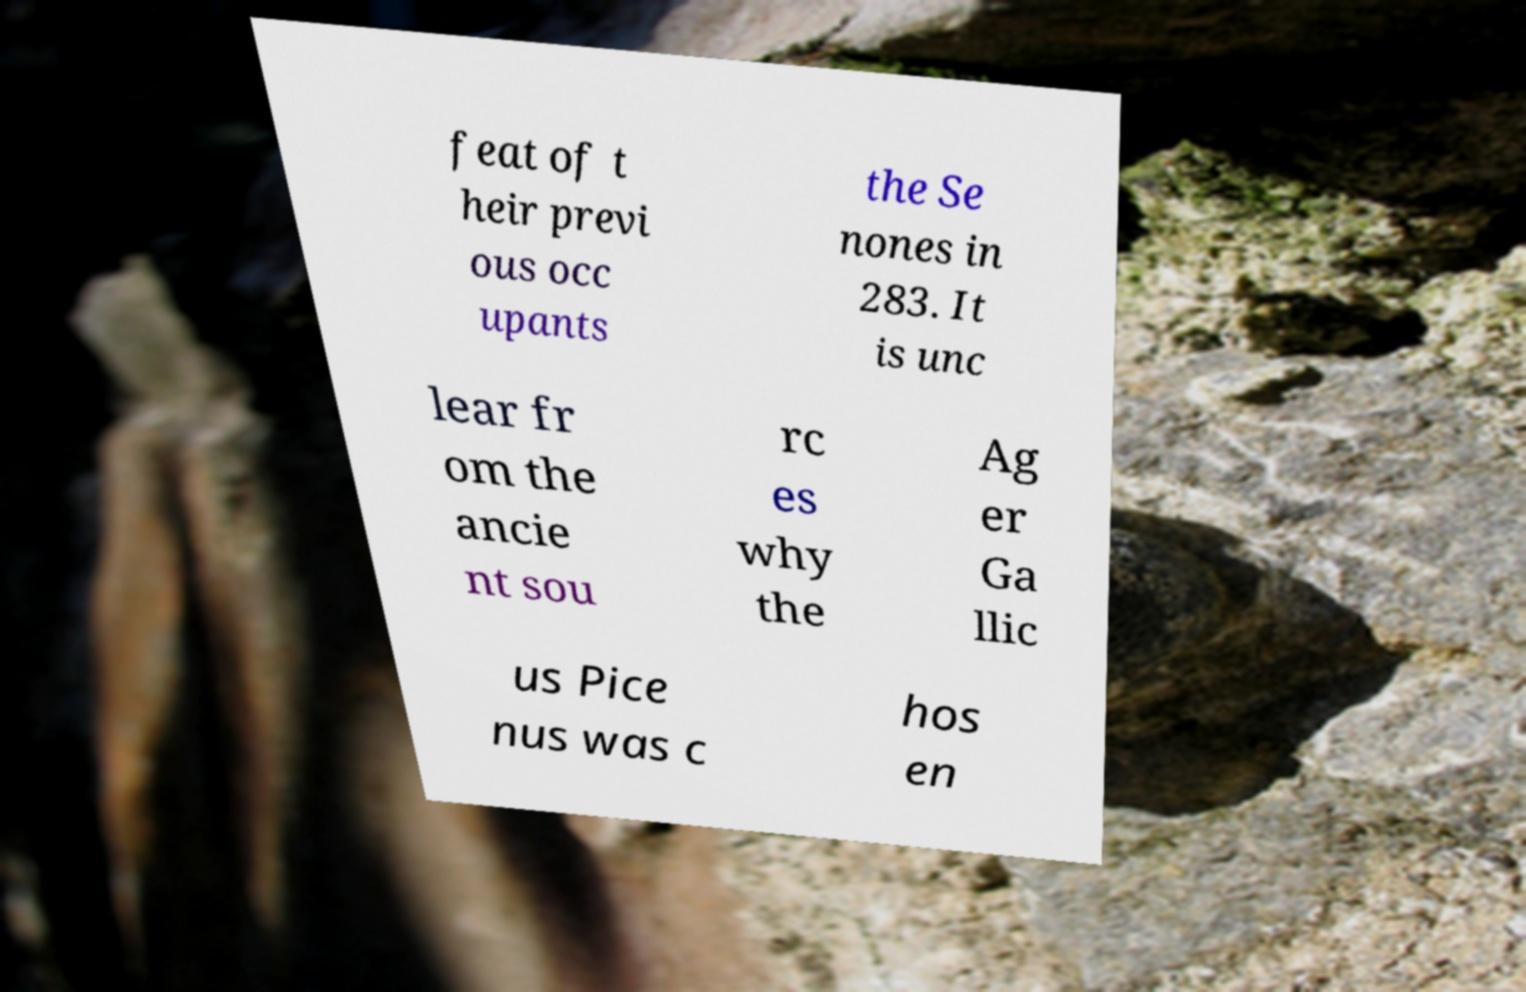Could you extract and type out the text from this image? feat of t heir previ ous occ upants the Se nones in 283. It is unc lear fr om the ancie nt sou rc es why the Ag er Ga llic us Pice nus was c hos en 